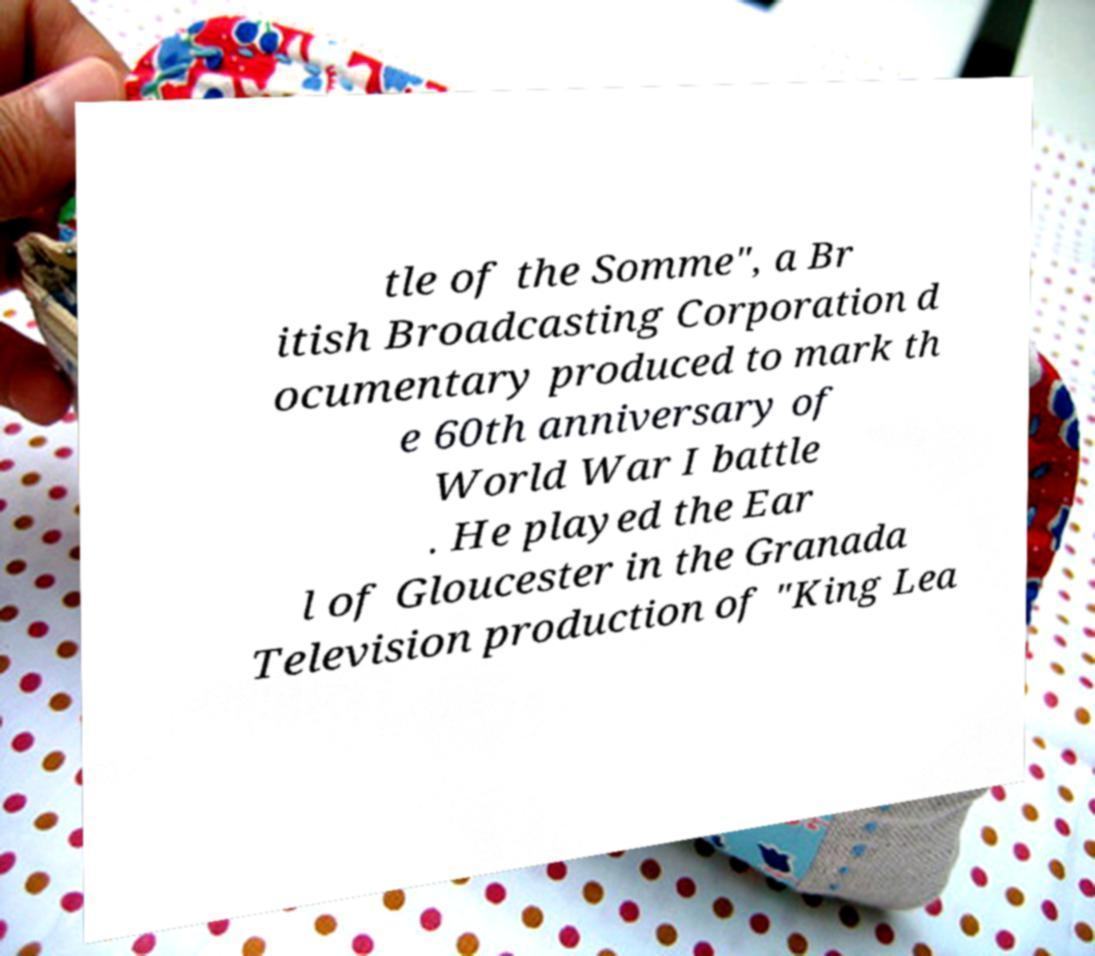Please read and relay the text visible in this image. What does it say? tle of the Somme", a Br itish Broadcasting Corporation d ocumentary produced to mark th e 60th anniversary of World War I battle . He played the Ear l of Gloucester in the Granada Television production of "King Lea 